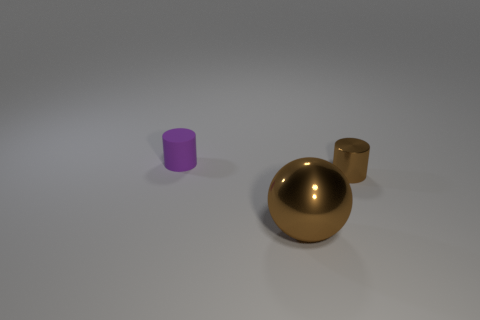The thing that is the same size as the purple matte cylinder is what shape?
Provide a succinct answer. Cylinder. Is there a object of the same color as the big sphere?
Provide a short and direct response. Yes. Are there the same number of large shiny spheres that are in front of the big sphere and brown shiny balls?
Ensure brevity in your answer.  No. Do the large metal ball and the matte cylinder have the same color?
Offer a terse response. No. How big is the thing that is both behind the ball and on the right side of the rubber thing?
Your answer should be compact. Small. The thing that is the same material as the brown cylinder is what color?
Make the answer very short. Brown. What number of big purple balls have the same material as the big thing?
Make the answer very short. 0. Is the number of small metal things in front of the brown shiny cylinder the same as the number of objects that are left of the tiny purple thing?
Ensure brevity in your answer.  Yes. Do the purple matte object and the brown metallic thing left of the tiny brown thing have the same shape?
Offer a terse response. No. There is a tiny cylinder that is the same color as the ball; what is its material?
Ensure brevity in your answer.  Metal. 